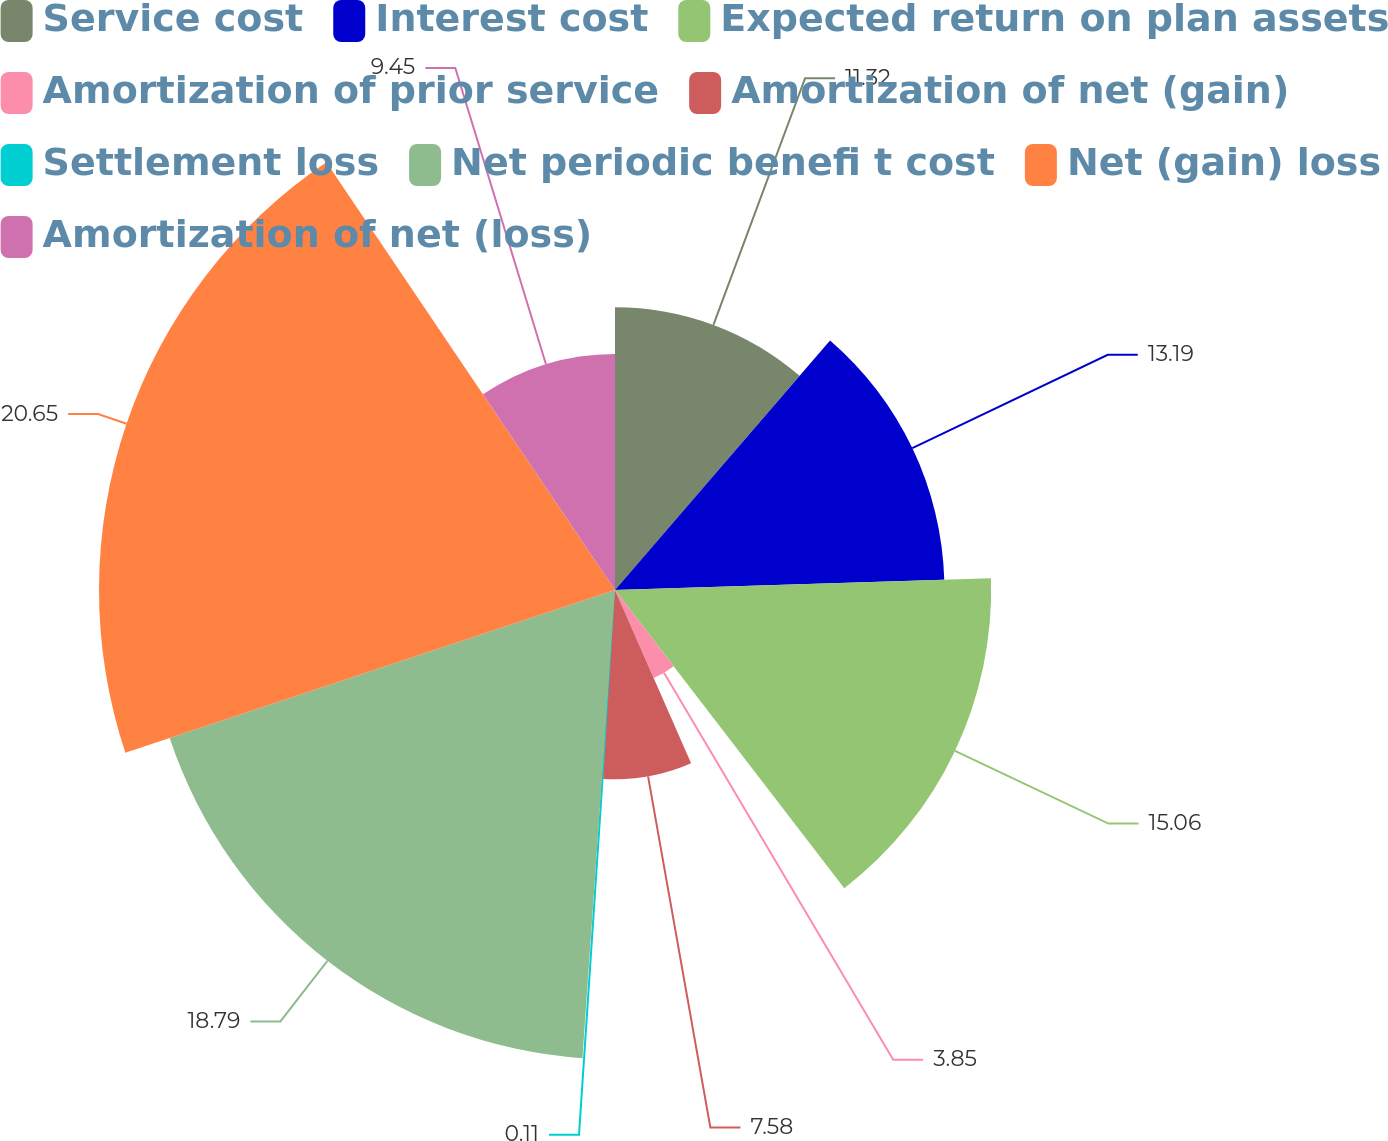Convert chart. <chart><loc_0><loc_0><loc_500><loc_500><pie_chart><fcel>Service cost<fcel>Interest cost<fcel>Expected return on plan assets<fcel>Amortization of prior service<fcel>Amortization of net (gain)<fcel>Settlement loss<fcel>Net periodic benefi t cost<fcel>Net (gain) loss<fcel>Amortization of net (loss)<nl><fcel>11.32%<fcel>13.19%<fcel>15.06%<fcel>3.85%<fcel>7.58%<fcel>0.11%<fcel>18.79%<fcel>20.66%<fcel>9.45%<nl></chart> 